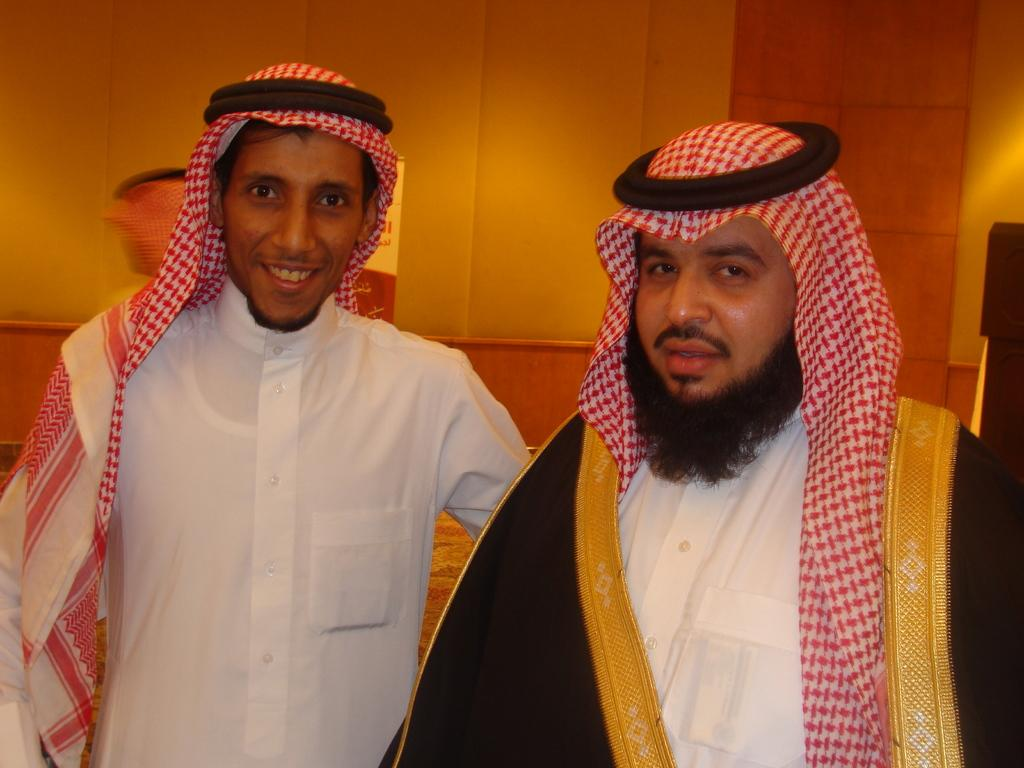How many people are in the image? There are two persons in the image. Where are the two persons located in relation to the image? The two persons are in front. What is visible behind the two persons? There is a wall behind the two persons. What is the degree of motion exhibited by the hands of the two persons in the image? There is no information about the hands of the two persons in the image, so it is not possible to determine the degree of motion. 